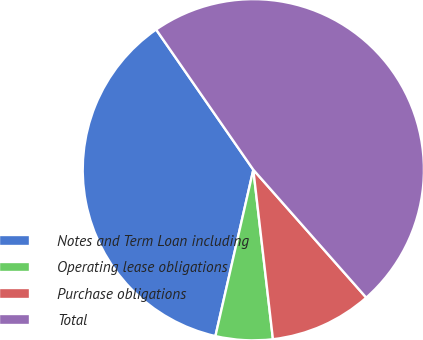Convert chart to OTSL. <chart><loc_0><loc_0><loc_500><loc_500><pie_chart><fcel>Notes and Term Loan including<fcel>Operating lease obligations<fcel>Purchase obligations<fcel>Total<nl><fcel>36.79%<fcel>5.4%<fcel>9.68%<fcel>48.14%<nl></chart> 